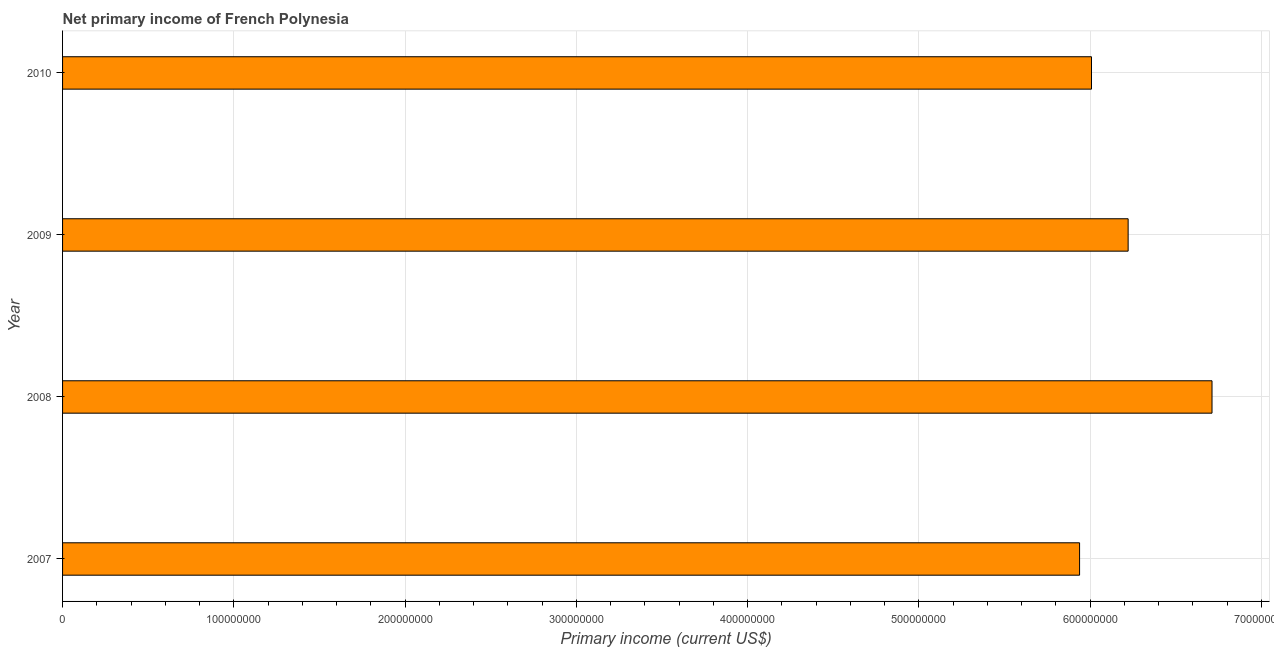What is the title of the graph?
Your response must be concise. Net primary income of French Polynesia. What is the label or title of the X-axis?
Provide a succinct answer. Primary income (current US$). What is the amount of primary income in 2010?
Ensure brevity in your answer.  6.01e+08. Across all years, what is the maximum amount of primary income?
Offer a terse response. 6.71e+08. Across all years, what is the minimum amount of primary income?
Keep it short and to the point. 5.94e+08. In which year was the amount of primary income maximum?
Your response must be concise. 2008. What is the sum of the amount of primary income?
Your response must be concise. 2.49e+09. What is the difference between the amount of primary income in 2007 and 2009?
Your answer should be compact. -2.84e+07. What is the average amount of primary income per year?
Offer a very short reply. 6.22e+08. What is the median amount of primary income?
Your answer should be very brief. 6.12e+08. In how many years, is the amount of primary income greater than 560000000 US$?
Offer a very short reply. 4. Do a majority of the years between 2009 and 2010 (inclusive) have amount of primary income greater than 100000000 US$?
Provide a short and direct response. Yes. What is the difference between the highest and the second highest amount of primary income?
Your answer should be very brief. 4.90e+07. What is the difference between the highest and the lowest amount of primary income?
Offer a very short reply. 7.73e+07. How many bars are there?
Give a very brief answer. 4. Are all the bars in the graph horizontal?
Your response must be concise. Yes. What is the difference between two consecutive major ticks on the X-axis?
Ensure brevity in your answer.  1.00e+08. What is the Primary income (current US$) in 2007?
Provide a succinct answer. 5.94e+08. What is the Primary income (current US$) of 2008?
Provide a succinct answer. 6.71e+08. What is the Primary income (current US$) of 2009?
Ensure brevity in your answer.  6.22e+08. What is the Primary income (current US$) in 2010?
Offer a terse response. 6.01e+08. What is the difference between the Primary income (current US$) in 2007 and 2008?
Offer a very short reply. -7.73e+07. What is the difference between the Primary income (current US$) in 2007 and 2009?
Give a very brief answer. -2.84e+07. What is the difference between the Primary income (current US$) in 2007 and 2010?
Give a very brief answer. -6.95e+06. What is the difference between the Primary income (current US$) in 2008 and 2009?
Give a very brief answer. 4.90e+07. What is the difference between the Primary income (current US$) in 2008 and 2010?
Keep it short and to the point. 7.04e+07. What is the difference between the Primary income (current US$) in 2009 and 2010?
Offer a terse response. 2.14e+07. What is the ratio of the Primary income (current US$) in 2007 to that in 2008?
Your response must be concise. 0.89. What is the ratio of the Primary income (current US$) in 2007 to that in 2009?
Offer a terse response. 0.95. What is the ratio of the Primary income (current US$) in 2007 to that in 2010?
Offer a terse response. 0.99. What is the ratio of the Primary income (current US$) in 2008 to that in 2009?
Offer a terse response. 1.08. What is the ratio of the Primary income (current US$) in 2008 to that in 2010?
Provide a short and direct response. 1.12. What is the ratio of the Primary income (current US$) in 2009 to that in 2010?
Make the answer very short. 1.04. 